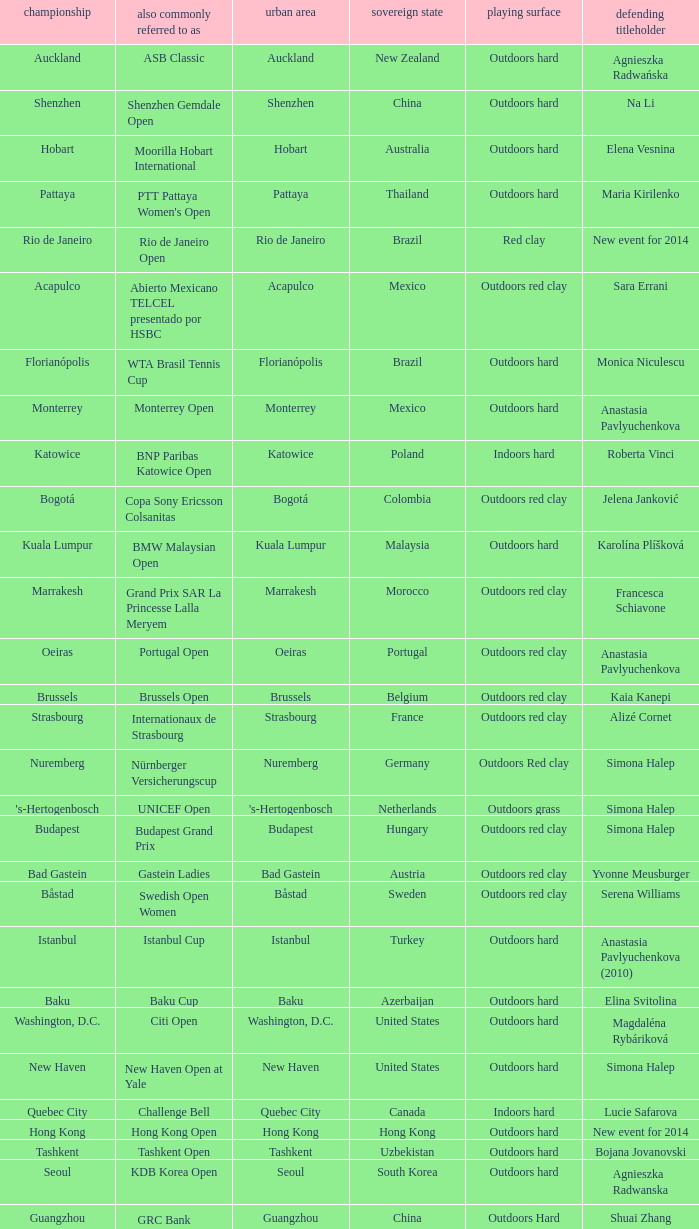How many tournaments are also currently known as the hp open? 1.0. 